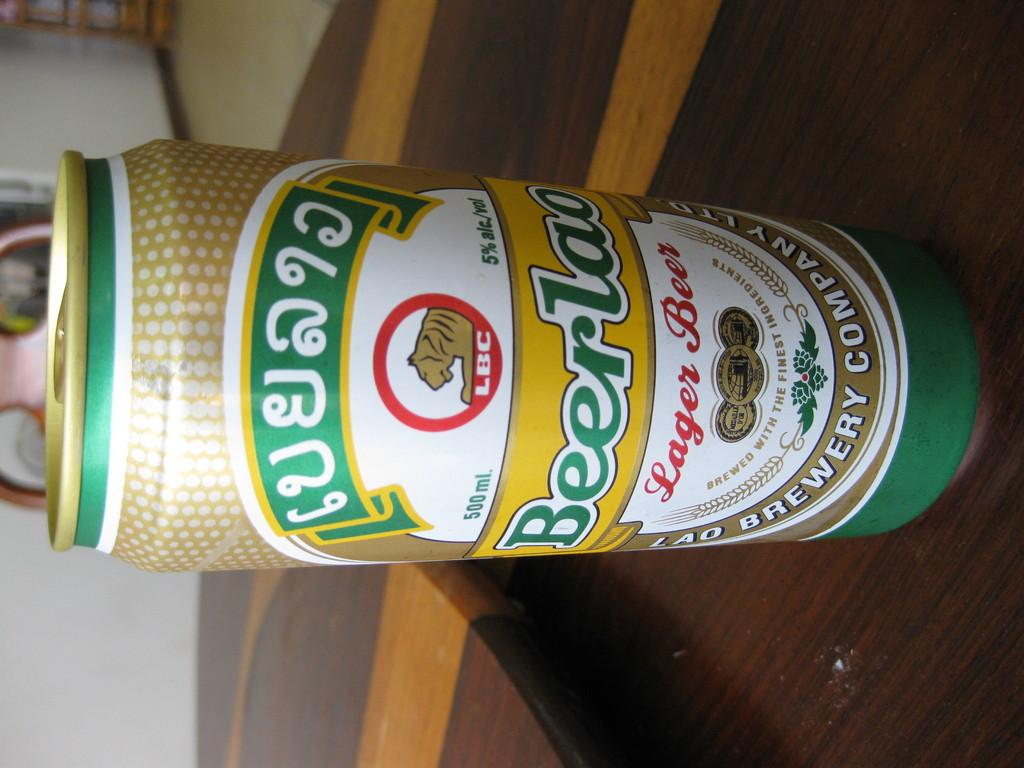<image>
Describe the image concisely. A 500 ml can of Beer Lao has 5% alc./vol. 